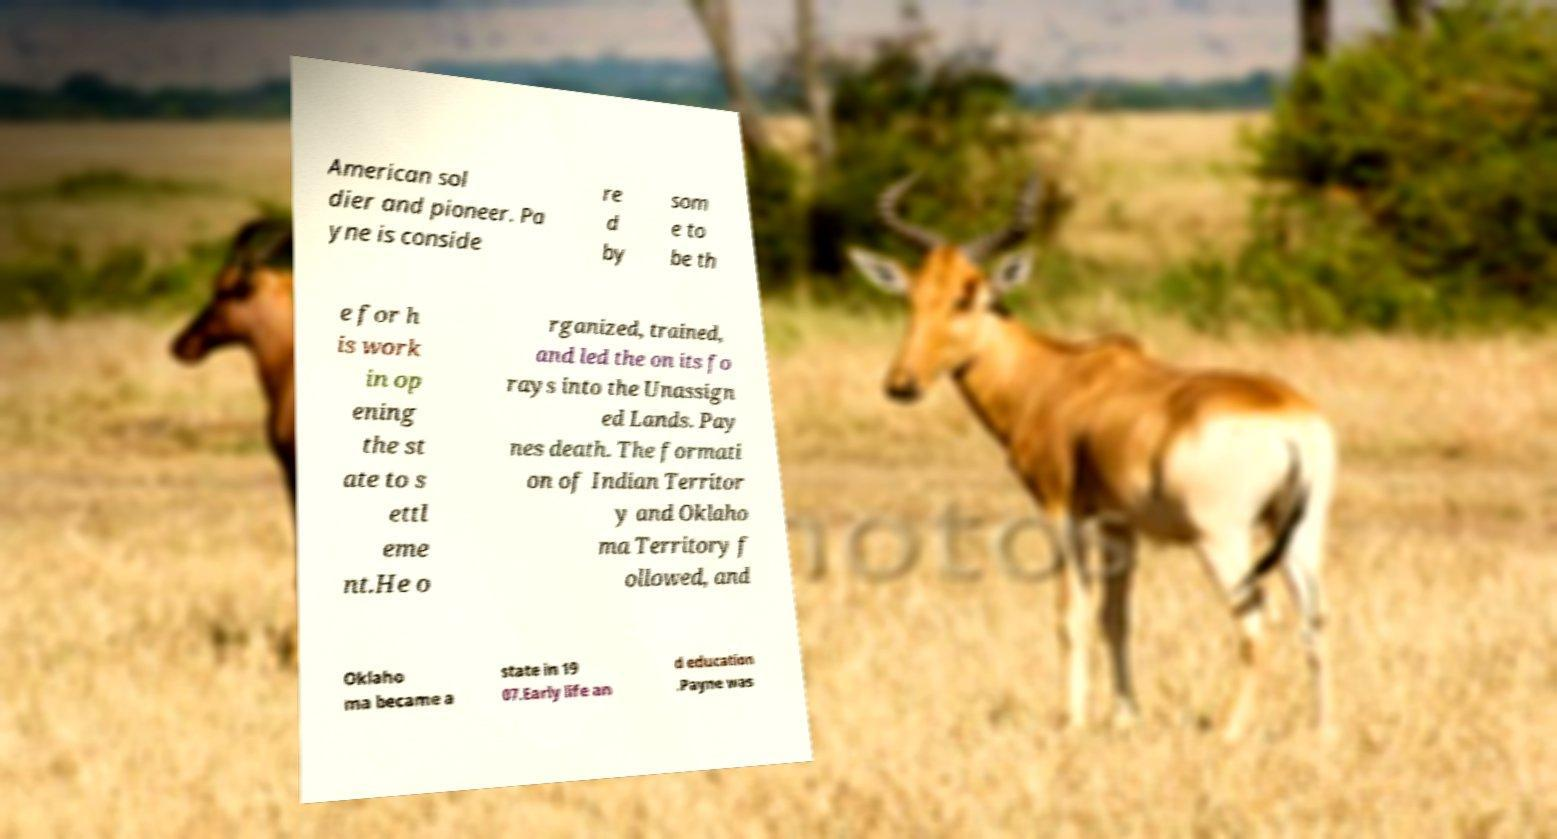Can you accurately transcribe the text from the provided image for me? American sol dier and pioneer. Pa yne is conside re d by som e to be th e for h is work in op ening the st ate to s ettl eme nt.He o rganized, trained, and led the on its fo rays into the Unassign ed Lands. Pay nes death. The formati on of Indian Territor y and Oklaho ma Territory f ollowed, and Oklaho ma became a state in 19 07.Early life an d education .Payne was 